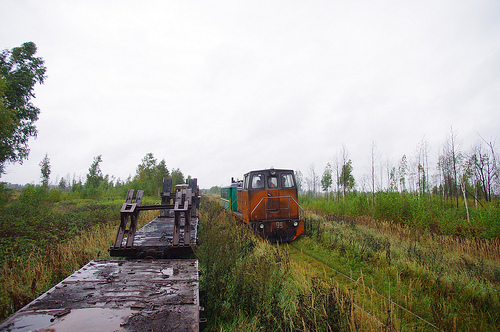Considering the environment, what kinds of wildlife might inhabit this area? An area like this, with dense grasses and an apparent abundance of water, could support a variety of wildlife. One might find small mammals like rodents or rabbits, birds that thrive in open fields, and various insects that are attracted to wet, grassy conditions. The region might also serve as a habitat for amphibians and if there are bodies of water nearby, fish and aquatic invertebrates. 